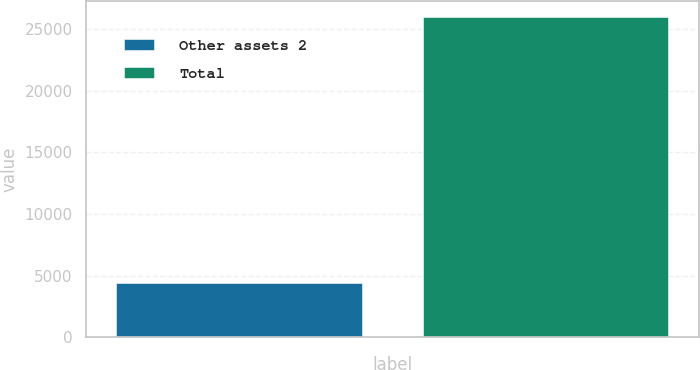<chart> <loc_0><loc_0><loc_500><loc_500><bar_chart><fcel>Other assets 2<fcel>Total<nl><fcel>4420<fcel>25969<nl></chart> 